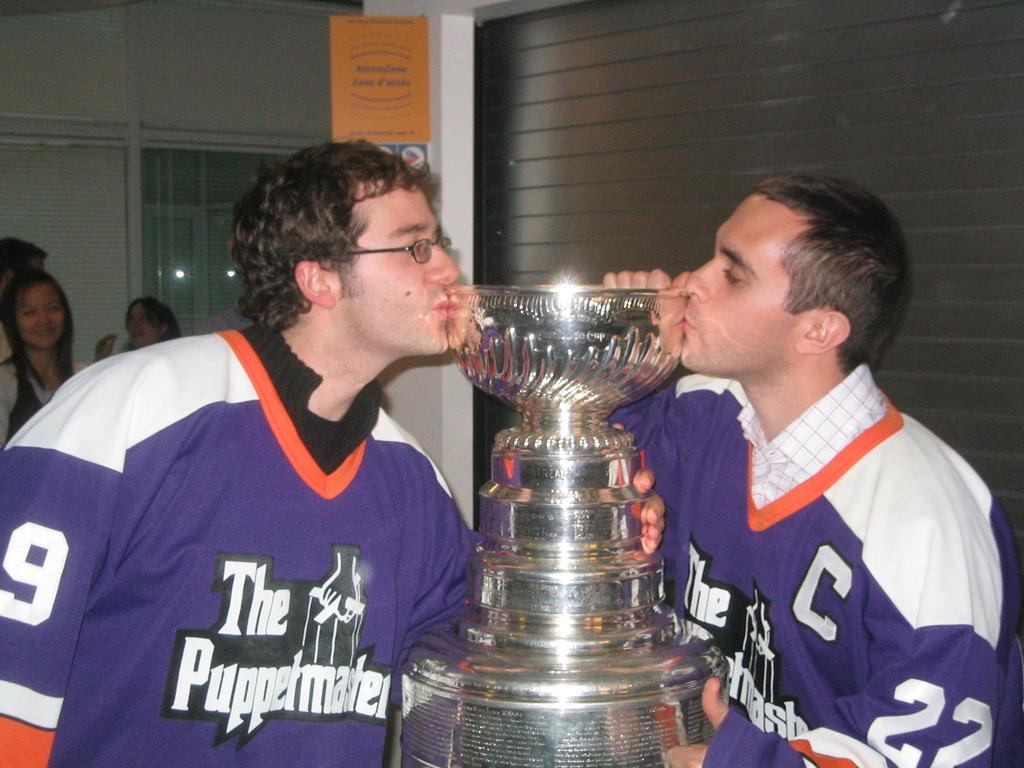What team do the players play for?
Offer a terse response. The puppetmasters. What number is on the jersey to the right?
Your response must be concise. 22. 